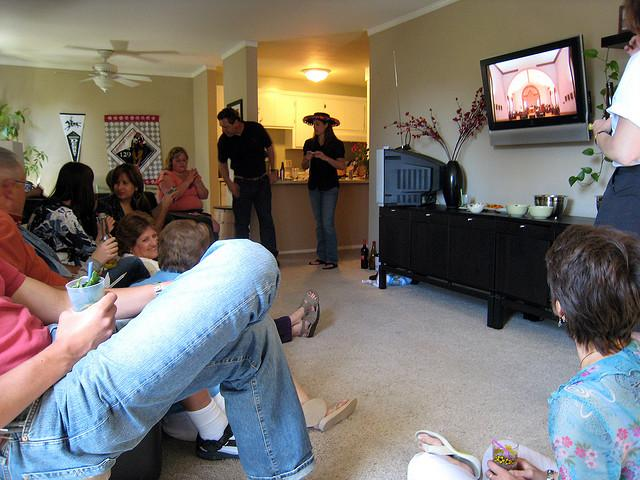What are the people looking at in the room? television 